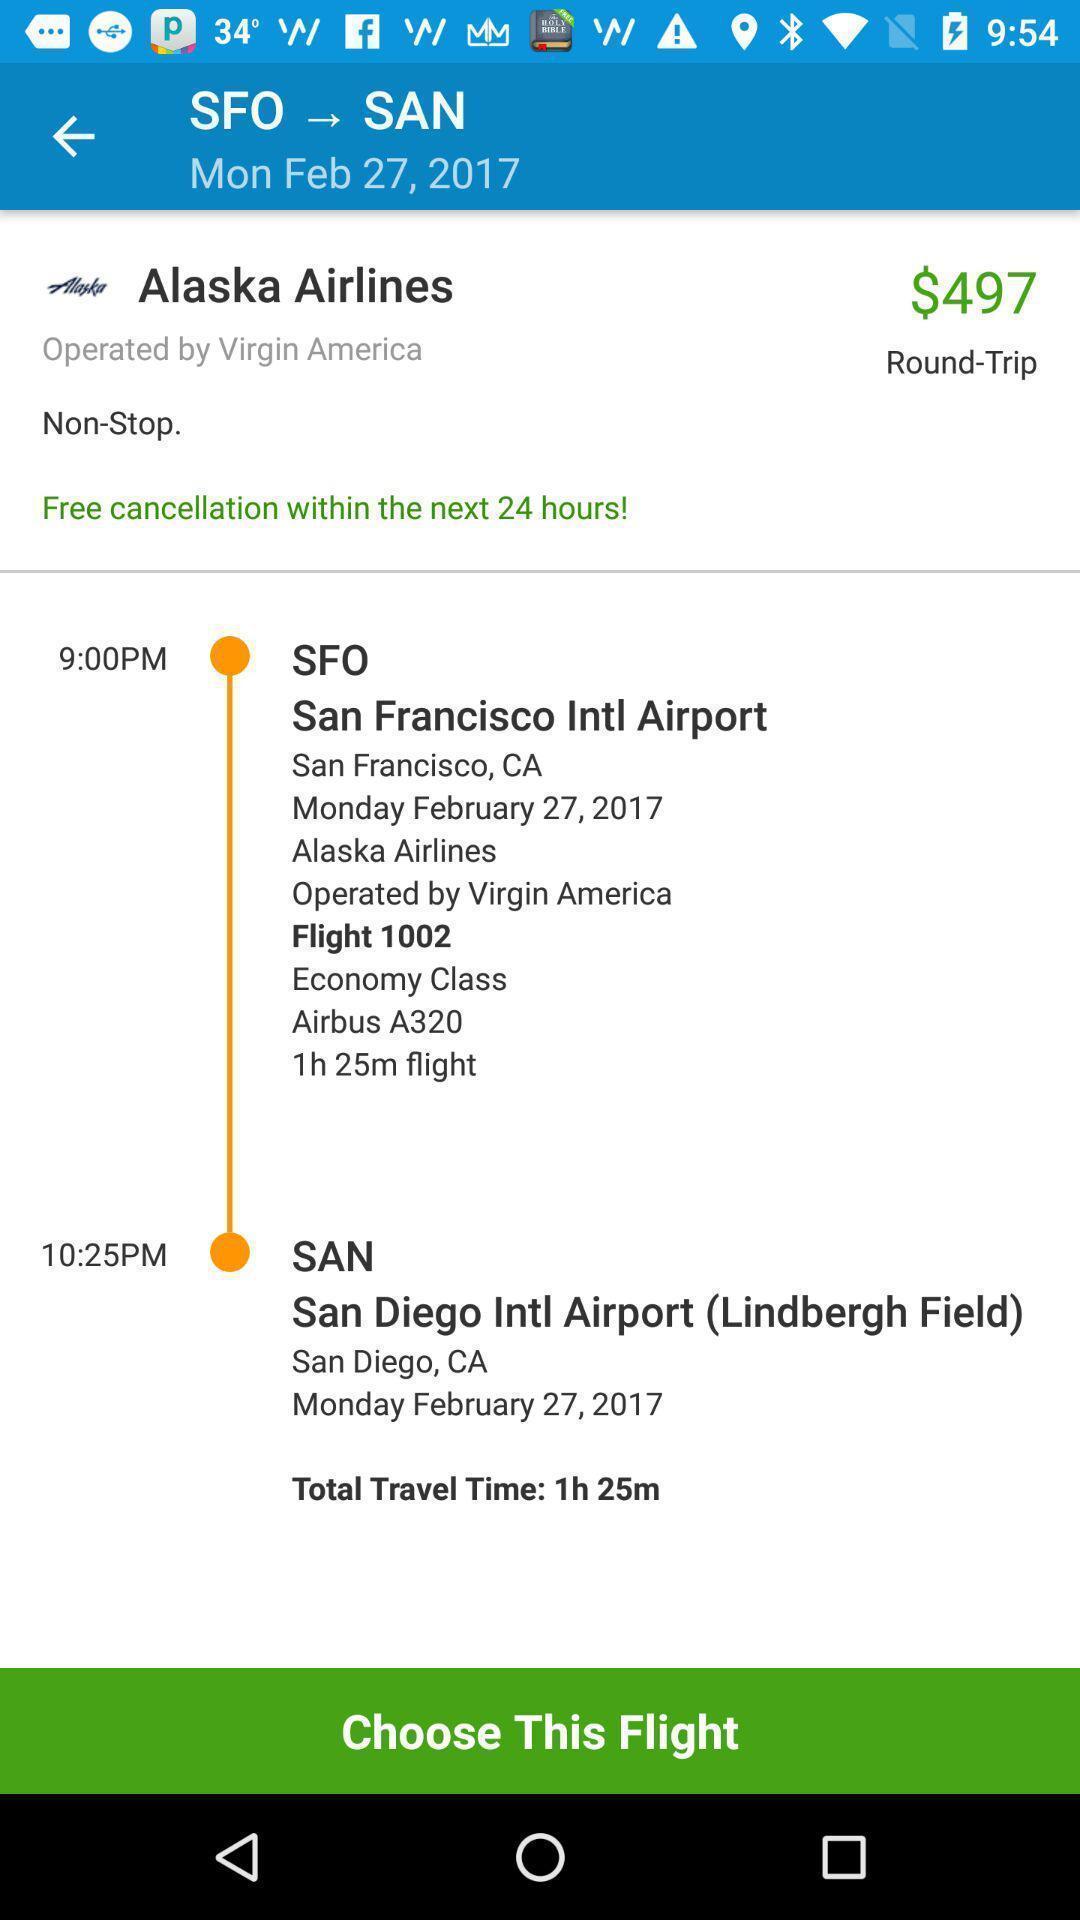Give me a narrative description of this picture. Page that displaying airlines application. 